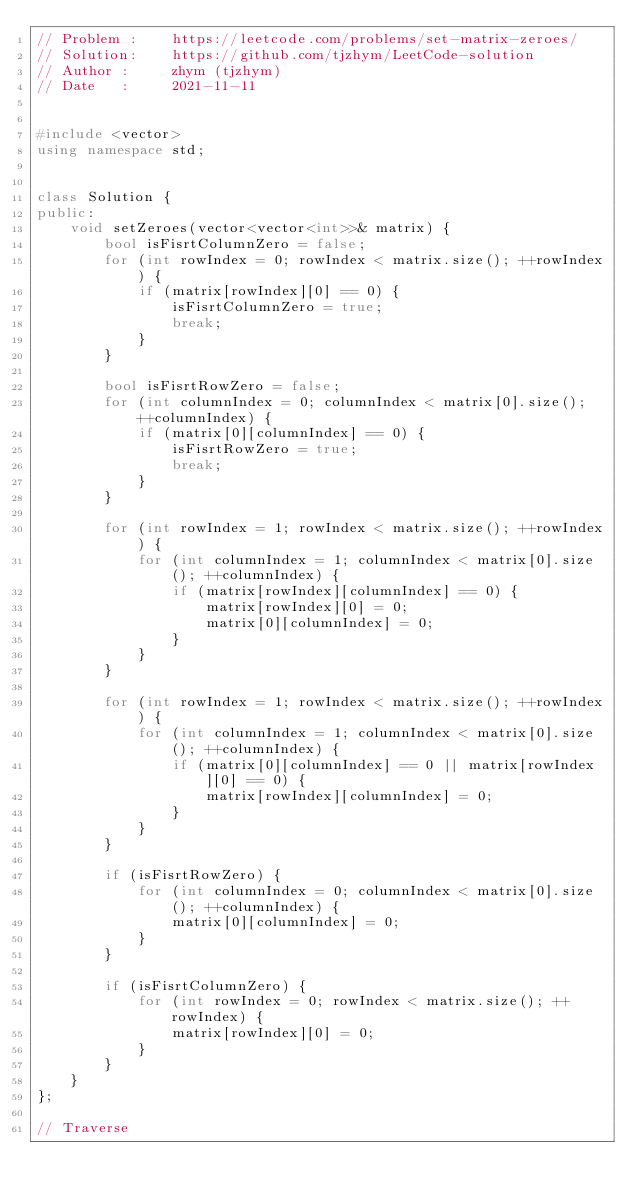<code> <loc_0><loc_0><loc_500><loc_500><_C++_>// Problem :    https://leetcode.com/problems/set-matrix-zeroes/
// Solution:    https://github.com/tjzhym/LeetCode-solution
// Author :     zhym (tjzhym)
// Date   :     2021-11-11


#include <vector>
using namespace std;


class Solution {
public:
    void setZeroes(vector<vector<int>>& matrix) {
        bool isFisrtColumnZero = false;
        for (int rowIndex = 0; rowIndex < matrix.size(); ++rowIndex) {
            if (matrix[rowIndex][0] == 0) {
                isFisrtColumnZero = true;
                break;
            }
        }

        bool isFisrtRowZero = false;
        for (int columnIndex = 0; columnIndex < matrix[0].size(); ++columnIndex) {
            if (matrix[0][columnIndex] == 0) {
                isFisrtRowZero = true;
                break;
            }
        }

        for (int rowIndex = 1; rowIndex < matrix.size(); ++rowIndex) {
            for (int columnIndex = 1; columnIndex < matrix[0].size(); ++columnIndex) {
                if (matrix[rowIndex][columnIndex] == 0) {
                    matrix[rowIndex][0] = 0;
                    matrix[0][columnIndex] = 0;
                }
            }
        }

        for (int rowIndex = 1; rowIndex < matrix.size(); ++rowIndex) {
            for (int columnIndex = 1; columnIndex < matrix[0].size(); ++columnIndex) {
                if (matrix[0][columnIndex] == 0 || matrix[rowIndex][0] == 0) {
                    matrix[rowIndex][columnIndex] = 0;
                }  
            }
        }

        if (isFisrtRowZero) {
            for (int columnIndex = 0; columnIndex < matrix[0].size(); ++columnIndex) {
                matrix[0][columnIndex] = 0;
            }
        }

        if (isFisrtColumnZero) {
            for (int rowIndex = 0; rowIndex < matrix.size(); ++rowIndex) {
                matrix[rowIndex][0] = 0;
            }
        }
    }
};

// Traverse</code> 